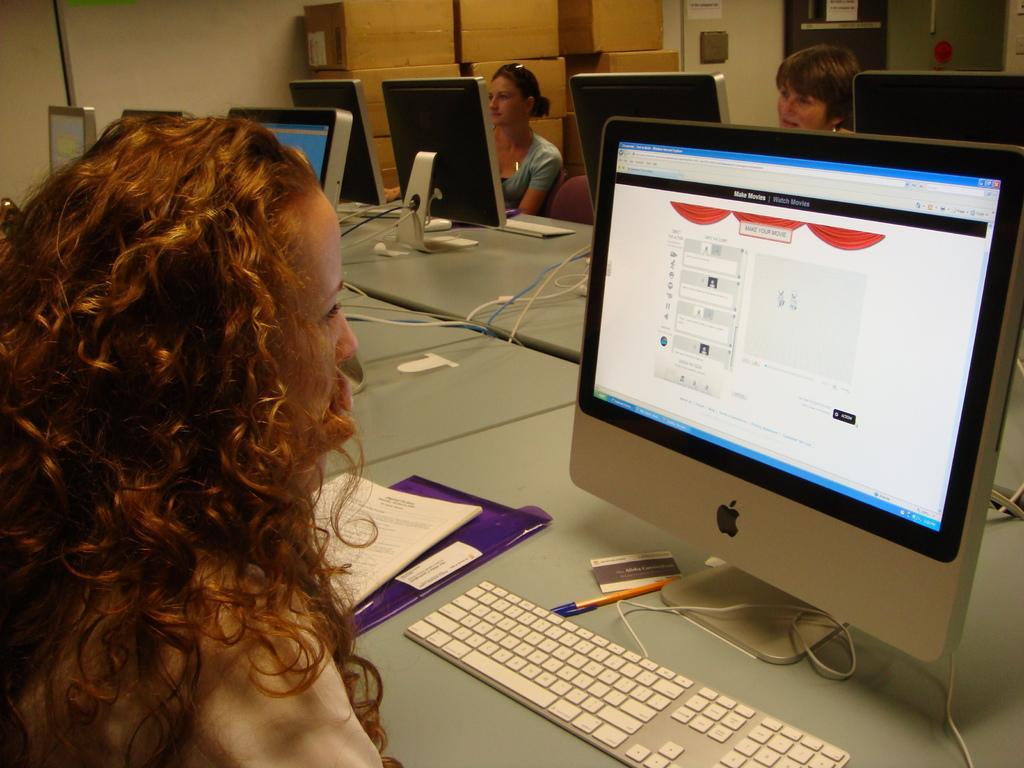Can you describe this image briefly? In the foreground of the image we can see a lady looking at the monitor. On the top of the image we can see two ladies operating the computers. 